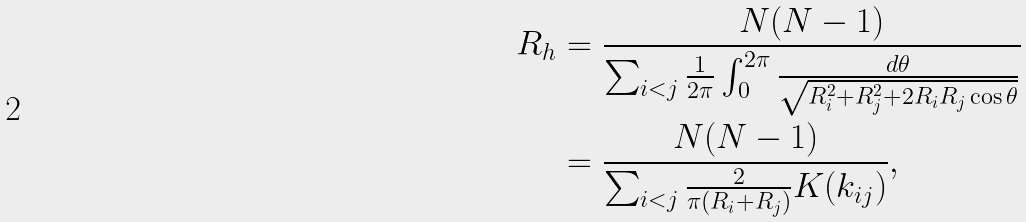Convert formula to latex. <formula><loc_0><loc_0><loc_500><loc_500>R _ { h } & = \frac { N ( N - 1 ) } { \sum _ { i < j } \frac { 1 } { 2 \pi } \int _ { 0 } ^ { 2 \pi } \frac { d \theta } { \sqrt { R _ { i } ^ { 2 } + R _ { j } ^ { 2 } + 2 R _ { i } R _ { j } \cos \theta } } } \\ & = \frac { N ( N - 1 ) } { \sum _ { i < j } \frac { 2 } { \pi ( R _ { i } + R _ { j } ) } K ( k _ { i j } ) } ,</formula> 